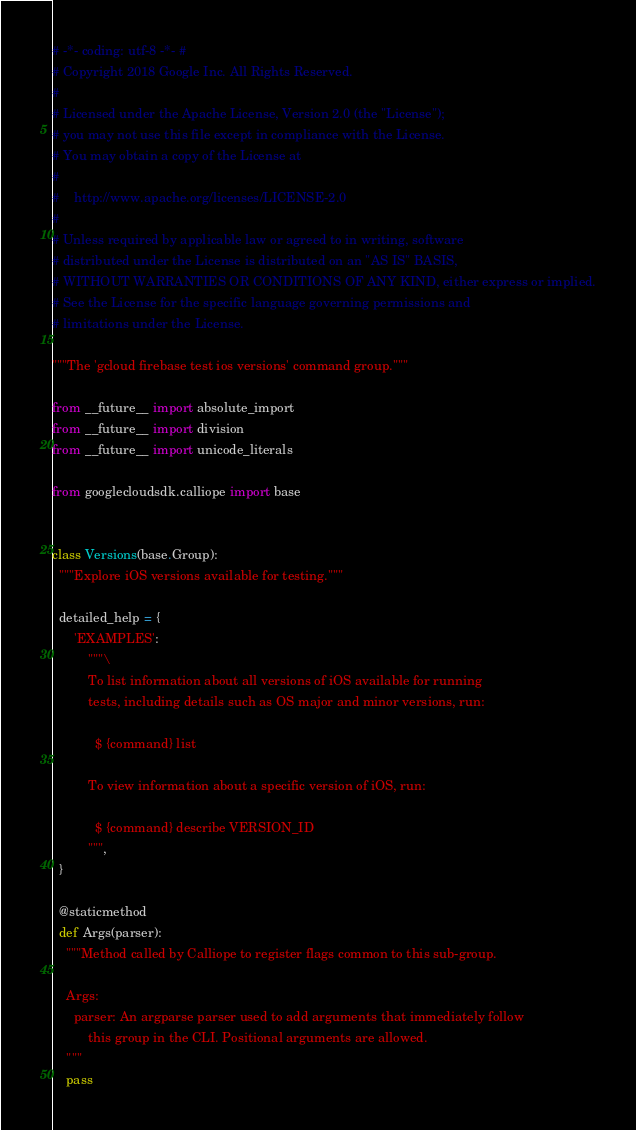Convert code to text. <code><loc_0><loc_0><loc_500><loc_500><_Python_># -*- coding: utf-8 -*- #
# Copyright 2018 Google Inc. All Rights Reserved.
#
# Licensed under the Apache License, Version 2.0 (the "License");
# you may not use this file except in compliance with the License.
# You may obtain a copy of the License at
#
#    http://www.apache.org/licenses/LICENSE-2.0
#
# Unless required by applicable law or agreed to in writing, software
# distributed under the License is distributed on an "AS IS" BASIS,
# WITHOUT WARRANTIES OR CONDITIONS OF ANY KIND, either express or implied.
# See the License for the specific language governing permissions and
# limitations under the License.

"""The 'gcloud firebase test ios versions' command group."""

from __future__ import absolute_import
from __future__ import division
from __future__ import unicode_literals

from googlecloudsdk.calliope import base


class Versions(base.Group):
  """Explore iOS versions available for testing."""

  detailed_help = {
      'EXAMPLES':
          """\
          To list information about all versions of iOS available for running
          tests, including details such as OS major and minor versions, run:

            $ {command} list

          To view information about a specific version of iOS, run:

            $ {command} describe VERSION_ID
          """,
  }

  @staticmethod
  def Args(parser):
    """Method called by Calliope to register flags common to this sub-group.

    Args:
      parser: An argparse parser used to add arguments that immediately follow
          this group in the CLI. Positional arguments are allowed.
    """
    pass
</code> 